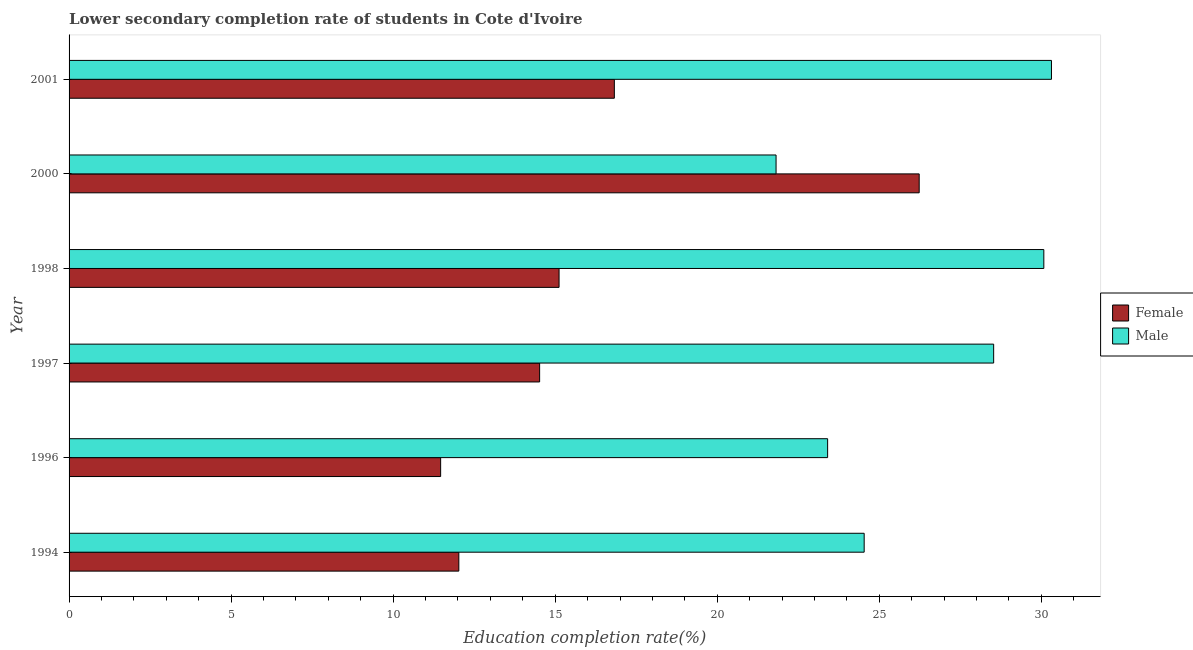Are the number of bars on each tick of the Y-axis equal?
Give a very brief answer. Yes. What is the label of the 5th group of bars from the top?
Your answer should be compact. 1996. What is the education completion rate of female students in 2001?
Keep it short and to the point. 16.83. Across all years, what is the maximum education completion rate of female students?
Give a very brief answer. 26.23. Across all years, what is the minimum education completion rate of male students?
Keep it short and to the point. 21.82. In which year was the education completion rate of female students maximum?
Your response must be concise. 2000. In which year was the education completion rate of female students minimum?
Give a very brief answer. 1996. What is the total education completion rate of male students in the graph?
Give a very brief answer. 158.68. What is the difference between the education completion rate of female students in 1998 and that in 2000?
Ensure brevity in your answer.  -11.11. What is the difference between the education completion rate of female students in 1998 and the education completion rate of male students in 2001?
Your answer should be very brief. -15.19. What is the average education completion rate of female students per year?
Your response must be concise. 16.03. In the year 1997, what is the difference between the education completion rate of male students and education completion rate of female students?
Your answer should be compact. 14.01. What is the ratio of the education completion rate of female students in 1997 to that in 2001?
Ensure brevity in your answer.  0.86. Is the education completion rate of male students in 1998 less than that in 2001?
Ensure brevity in your answer.  Yes. Is the difference between the education completion rate of female students in 1994 and 1997 greater than the difference between the education completion rate of male students in 1994 and 1997?
Make the answer very short. Yes. What is the difference between the highest and the second highest education completion rate of male students?
Keep it short and to the point. 0.24. In how many years, is the education completion rate of male students greater than the average education completion rate of male students taken over all years?
Offer a very short reply. 3. What does the 2nd bar from the top in 2000 represents?
Give a very brief answer. Female. What does the 2nd bar from the bottom in 1998 represents?
Give a very brief answer. Male. How many years are there in the graph?
Keep it short and to the point. 6. What is the difference between two consecutive major ticks on the X-axis?
Provide a short and direct response. 5. How many legend labels are there?
Your answer should be very brief. 2. How are the legend labels stacked?
Offer a terse response. Vertical. What is the title of the graph?
Keep it short and to the point. Lower secondary completion rate of students in Cote d'Ivoire. Does "Crop" appear as one of the legend labels in the graph?
Give a very brief answer. No. What is the label or title of the X-axis?
Your response must be concise. Education completion rate(%). What is the label or title of the Y-axis?
Your response must be concise. Year. What is the Education completion rate(%) in Female in 1994?
Make the answer very short. 12.03. What is the Education completion rate(%) of Male in 1994?
Make the answer very short. 24.53. What is the Education completion rate(%) of Female in 1996?
Make the answer very short. 11.47. What is the Education completion rate(%) in Male in 1996?
Make the answer very short. 23.41. What is the Education completion rate(%) in Female in 1997?
Offer a very short reply. 14.52. What is the Education completion rate(%) of Male in 1997?
Your answer should be very brief. 28.53. What is the Education completion rate(%) of Female in 1998?
Your answer should be compact. 15.12. What is the Education completion rate(%) of Male in 1998?
Give a very brief answer. 30.08. What is the Education completion rate(%) of Female in 2000?
Make the answer very short. 26.23. What is the Education completion rate(%) of Male in 2000?
Your response must be concise. 21.82. What is the Education completion rate(%) in Female in 2001?
Your response must be concise. 16.83. What is the Education completion rate(%) of Male in 2001?
Provide a succinct answer. 30.31. Across all years, what is the maximum Education completion rate(%) of Female?
Your answer should be very brief. 26.23. Across all years, what is the maximum Education completion rate(%) of Male?
Your response must be concise. 30.31. Across all years, what is the minimum Education completion rate(%) in Female?
Provide a succinct answer. 11.47. Across all years, what is the minimum Education completion rate(%) of Male?
Your answer should be very brief. 21.82. What is the total Education completion rate(%) of Female in the graph?
Give a very brief answer. 96.19. What is the total Education completion rate(%) in Male in the graph?
Keep it short and to the point. 158.68. What is the difference between the Education completion rate(%) in Female in 1994 and that in 1996?
Give a very brief answer. 0.56. What is the difference between the Education completion rate(%) in Male in 1994 and that in 1996?
Provide a short and direct response. 1.13. What is the difference between the Education completion rate(%) in Female in 1994 and that in 1997?
Your response must be concise. -2.49. What is the difference between the Education completion rate(%) of Male in 1994 and that in 1997?
Offer a terse response. -4. What is the difference between the Education completion rate(%) of Female in 1994 and that in 1998?
Ensure brevity in your answer.  -3.09. What is the difference between the Education completion rate(%) of Male in 1994 and that in 1998?
Make the answer very short. -5.54. What is the difference between the Education completion rate(%) in Female in 1994 and that in 2000?
Provide a short and direct response. -14.21. What is the difference between the Education completion rate(%) of Male in 1994 and that in 2000?
Ensure brevity in your answer.  2.72. What is the difference between the Education completion rate(%) in Female in 1994 and that in 2001?
Offer a terse response. -4.8. What is the difference between the Education completion rate(%) in Male in 1994 and that in 2001?
Offer a very short reply. -5.78. What is the difference between the Education completion rate(%) in Female in 1996 and that in 1997?
Offer a terse response. -3.05. What is the difference between the Education completion rate(%) of Male in 1996 and that in 1997?
Make the answer very short. -5.12. What is the difference between the Education completion rate(%) in Female in 1996 and that in 1998?
Keep it short and to the point. -3.65. What is the difference between the Education completion rate(%) in Male in 1996 and that in 1998?
Give a very brief answer. -6.67. What is the difference between the Education completion rate(%) in Female in 1996 and that in 2000?
Your answer should be compact. -14.77. What is the difference between the Education completion rate(%) in Male in 1996 and that in 2000?
Offer a terse response. 1.59. What is the difference between the Education completion rate(%) of Female in 1996 and that in 2001?
Provide a short and direct response. -5.36. What is the difference between the Education completion rate(%) of Male in 1996 and that in 2001?
Offer a terse response. -6.91. What is the difference between the Education completion rate(%) of Female in 1997 and that in 1998?
Provide a short and direct response. -0.6. What is the difference between the Education completion rate(%) of Male in 1997 and that in 1998?
Make the answer very short. -1.55. What is the difference between the Education completion rate(%) of Female in 1997 and that in 2000?
Offer a terse response. -11.71. What is the difference between the Education completion rate(%) of Male in 1997 and that in 2000?
Provide a short and direct response. 6.71. What is the difference between the Education completion rate(%) of Female in 1997 and that in 2001?
Ensure brevity in your answer.  -2.31. What is the difference between the Education completion rate(%) in Male in 1997 and that in 2001?
Give a very brief answer. -1.78. What is the difference between the Education completion rate(%) of Female in 1998 and that in 2000?
Offer a very short reply. -11.11. What is the difference between the Education completion rate(%) in Male in 1998 and that in 2000?
Your answer should be very brief. 8.26. What is the difference between the Education completion rate(%) in Female in 1998 and that in 2001?
Your answer should be compact. -1.71. What is the difference between the Education completion rate(%) of Male in 1998 and that in 2001?
Offer a very short reply. -0.24. What is the difference between the Education completion rate(%) in Female in 2000 and that in 2001?
Provide a short and direct response. 9.41. What is the difference between the Education completion rate(%) in Male in 2000 and that in 2001?
Your response must be concise. -8.5. What is the difference between the Education completion rate(%) of Female in 1994 and the Education completion rate(%) of Male in 1996?
Ensure brevity in your answer.  -11.38. What is the difference between the Education completion rate(%) in Female in 1994 and the Education completion rate(%) in Male in 1997?
Offer a terse response. -16.5. What is the difference between the Education completion rate(%) in Female in 1994 and the Education completion rate(%) in Male in 1998?
Keep it short and to the point. -18.05. What is the difference between the Education completion rate(%) in Female in 1994 and the Education completion rate(%) in Male in 2000?
Your answer should be very brief. -9.79. What is the difference between the Education completion rate(%) of Female in 1994 and the Education completion rate(%) of Male in 2001?
Offer a terse response. -18.29. What is the difference between the Education completion rate(%) in Female in 1996 and the Education completion rate(%) in Male in 1997?
Your response must be concise. -17.06. What is the difference between the Education completion rate(%) in Female in 1996 and the Education completion rate(%) in Male in 1998?
Offer a terse response. -18.61. What is the difference between the Education completion rate(%) in Female in 1996 and the Education completion rate(%) in Male in 2000?
Offer a terse response. -10.35. What is the difference between the Education completion rate(%) of Female in 1996 and the Education completion rate(%) of Male in 2001?
Your response must be concise. -18.85. What is the difference between the Education completion rate(%) of Female in 1997 and the Education completion rate(%) of Male in 1998?
Provide a succinct answer. -15.56. What is the difference between the Education completion rate(%) in Female in 1997 and the Education completion rate(%) in Male in 2000?
Offer a very short reply. -7.3. What is the difference between the Education completion rate(%) of Female in 1997 and the Education completion rate(%) of Male in 2001?
Give a very brief answer. -15.79. What is the difference between the Education completion rate(%) in Female in 1998 and the Education completion rate(%) in Male in 2000?
Make the answer very short. -6.7. What is the difference between the Education completion rate(%) of Female in 1998 and the Education completion rate(%) of Male in 2001?
Offer a terse response. -15.19. What is the difference between the Education completion rate(%) of Female in 2000 and the Education completion rate(%) of Male in 2001?
Provide a succinct answer. -4.08. What is the average Education completion rate(%) of Female per year?
Your answer should be very brief. 16.03. What is the average Education completion rate(%) in Male per year?
Offer a terse response. 26.45. In the year 1994, what is the difference between the Education completion rate(%) in Female and Education completion rate(%) in Male?
Your answer should be compact. -12.51. In the year 1996, what is the difference between the Education completion rate(%) of Female and Education completion rate(%) of Male?
Give a very brief answer. -11.94. In the year 1997, what is the difference between the Education completion rate(%) of Female and Education completion rate(%) of Male?
Give a very brief answer. -14.01. In the year 1998, what is the difference between the Education completion rate(%) in Female and Education completion rate(%) in Male?
Ensure brevity in your answer.  -14.96. In the year 2000, what is the difference between the Education completion rate(%) of Female and Education completion rate(%) of Male?
Offer a very short reply. 4.42. In the year 2001, what is the difference between the Education completion rate(%) in Female and Education completion rate(%) in Male?
Keep it short and to the point. -13.49. What is the ratio of the Education completion rate(%) in Female in 1994 to that in 1996?
Your response must be concise. 1.05. What is the ratio of the Education completion rate(%) in Male in 1994 to that in 1996?
Keep it short and to the point. 1.05. What is the ratio of the Education completion rate(%) in Female in 1994 to that in 1997?
Provide a succinct answer. 0.83. What is the ratio of the Education completion rate(%) of Male in 1994 to that in 1997?
Make the answer very short. 0.86. What is the ratio of the Education completion rate(%) in Female in 1994 to that in 1998?
Ensure brevity in your answer.  0.8. What is the ratio of the Education completion rate(%) of Male in 1994 to that in 1998?
Make the answer very short. 0.82. What is the ratio of the Education completion rate(%) in Female in 1994 to that in 2000?
Give a very brief answer. 0.46. What is the ratio of the Education completion rate(%) in Male in 1994 to that in 2000?
Give a very brief answer. 1.12. What is the ratio of the Education completion rate(%) of Female in 1994 to that in 2001?
Ensure brevity in your answer.  0.71. What is the ratio of the Education completion rate(%) in Male in 1994 to that in 2001?
Ensure brevity in your answer.  0.81. What is the ratio of the Education completion rate(%) of Female in 1996 to that in 1997?
Your response must be concise. 0.79. What is the ratio of the Education completion rate(%) of Male in 1996 to that in 1997?
Offer a very short reply. 0.82. What is the ratio of the Education completion rate(%) of Female in 1996 to that in 1998?
Offer a very short reply. 0.76. What is the ratio of the Education completion rate(%) in Male in 1996 to that in 1998?
Provide a succinct answer. 0.78. What is the ratio of the Education completion rate(%) of Female in 1996 to that in 2000?
Your answer should be very brief. 0.44. What is the ratio of the Education completion rate(%) in Male in 1996 to that in 2000?
Ensure brevity in your answer.  1.07. What is the ratio of the Education completion rate(%) of Female in 1996 to that in 2001?
Make the answer very short. 0.68. What is the ratio of the Education completion rate(%) in Male in 1996 to that in 2001?
Your response must be concise. 0.77. What is the ratio of the Education completion rate(%) in Female in 1997 to that in 1998?
Make the answer very short. 0.96. What is the ratio of the Education completion rate(%) in Male in 1997 to that in 1998?
Offer a terse response. 0.95. What is the ratio of the Education completion rate(%) of Female in 1997 to that in 2000?
Your answer should be compact. 0.55. What is the ratio of the Education completion rate(%) of Male in 1997 to that in 2000?
Make the answer very short. 1.31. What is the ratio of the Education completion rate(%) in Female in 1997 to that in 2001?
Make the answer very short. 0.86. What is the ratio of the Education completion rate(%) of Female in 1998 to that in 2000?
Your answer should be very brief. 0.58. What is the ratio of the Education completion rate(%) of Male in 1998 to that in 2000?
Offer a very short reply. 1.38. What is the ratio of the Education completion rate(%) in Female in 1998 to that in 2001?
Keep it short and to the point. 0.9. What is the ratio of the Education completion rate(%) in Female in 2000 to that in 2001?
Keep it short and to the point. 1.56. What is the ratio of the Education completion rate(%) in Male in 2000 to that in 2001?
Make the answer very short. 0.72. What is the difference between the highest and the second highest Education completion rate(%) in Female?
Provide a short and direct response. 9.41. What is the difference between the highest and the second highest Education completion rate(%) in Male?
Provide a short and direct response. 0.24. What is the difference between the highest and the lowest Education completion rate(%) of Female?
Your answer should be compact. 14.77. What is the difference between the highest and the lowest Education completion rate(%) in Male?
Make the answer very short. 8.5. 